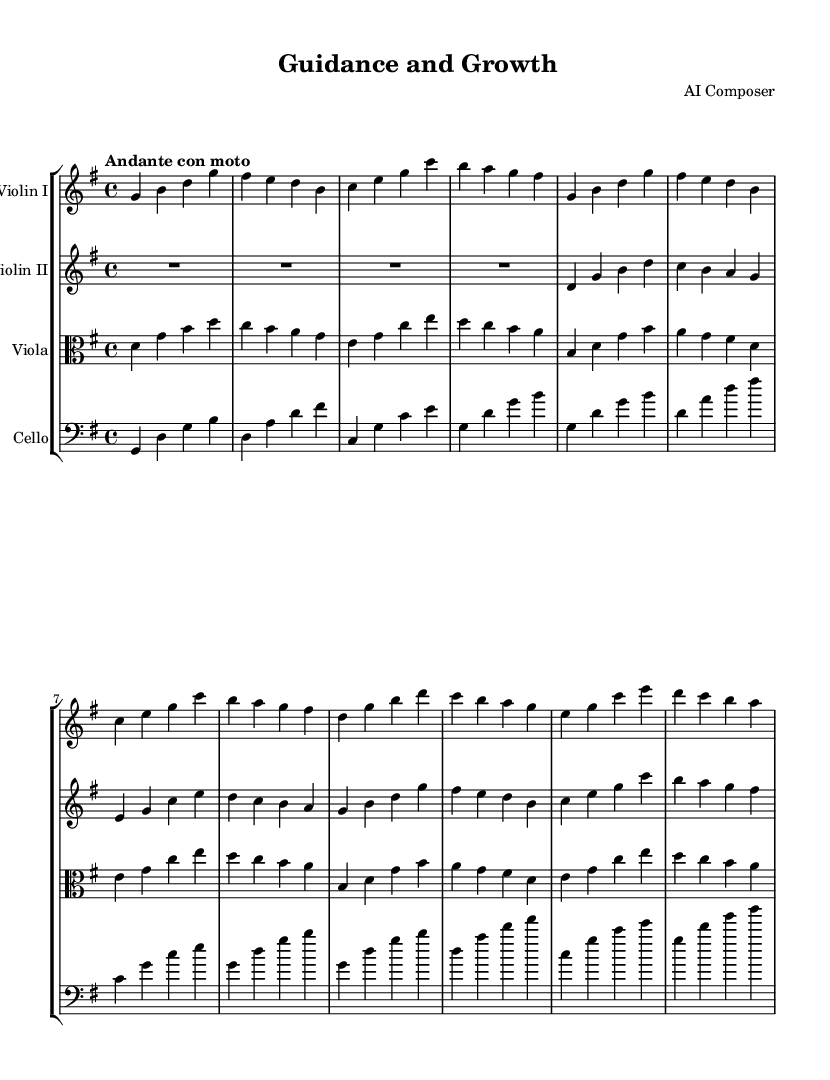What is the key signature of this music? The key signature is G major, which contains one sharp (F#). This can be determined by looking at the left side of the staff, where the key signature is indicated.
Answer: G major What is the time signature of this piece? The time signature indicated on the staff is 4/4, which means there are four beats per measure and a quarter note receives one beat. This is visible at the beginning of the score.
Answer: 4/4 What is the tempo marking of this piece? The tempo marking is "Andante con moto," which indicates a moderately slow tempo with some movement. This is also stated at the beginning of the score.
Answer: Andante con moto In which section does Theme A first appear for Violin I? Theme A first appears after the introduction, specifically at measure 5 for Violin I, as indicated by the note patterns which repeat. Examining the measures shows the thematic content where it starts.
Answer: Measure 5 Which instrument has the highest pitch range in this music? The instrument with the highest pitch range is Violin I, which primarily plays in the higher register compared to the other instruments in the quartet. This can be assessed by comparing the notes on the staffs of each instrument.
Answer: Violin I How many measures are there in the Introduction section? The Introduction section contains four measures, as can be counted by looking at the first few measures of the score before the themes begin.
Answer: 4 What are the two main themes represented in this piece? The two main themes are Theme A and Theme B, both of which are abbreviated in the score. They can be identified by their unique melodic material which is clearly labeled in the respective sections.
Answer: Theme A and Theme B 